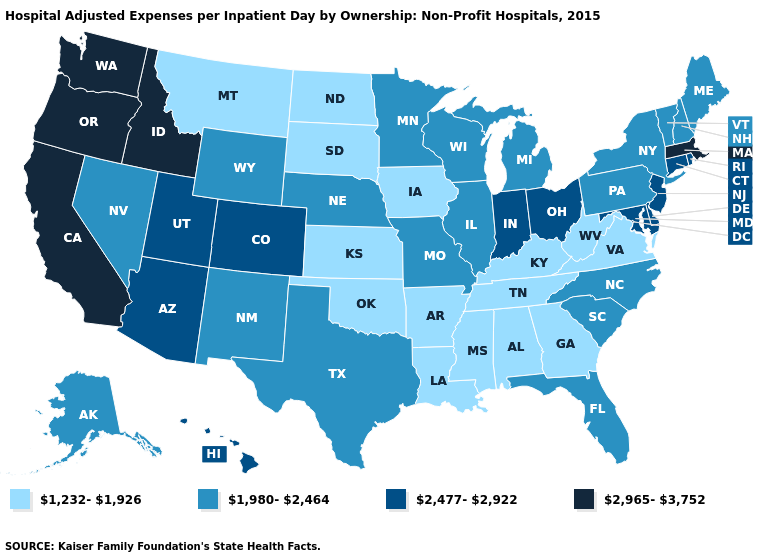Does New Jersey have the lowest value in the USA?
Be succinct. No. How many symbols are there in the legend?
Short answer required. 4. What is the highest value in the West ?
Be succinct. 2,965-3,752. Name the states that have a value in the range 2,477-2,922?
Write a very short answer. Arizona, Colorado, Connecticut, Delaware, Hawaii, Indiana, Maryland, New Jersey, Ohio, Rhode Island, Utah. Does Wisconsin have the lowest value in the USA?
Give a very brief answer. No. Does Kentucky have the same value as Arkansas?
Be succinct. Yes. Is the legend a continuous bar?
Write a very short answer. No. What is the lowest value in states that border Pennsylvania?
Short answer required. 1,232-1,926. What is the highest value in the West ?
Be succinct. 2,965-3,752. Name the states that have a value in the range 2,477-2,922?
Give a very brief answer. Arizona, Colorado, Connecticut, Delaware, Hawaii, Indiana, Maryland, New Jersey, Ohio, Rhode Island, Utah. Name the states that have a value in the range 2,965-3,752?
Quick response, please. California, Idaho, Massachusetts, Oregon, Washington. Among the states that border Illinois , does Wisconsin have the highest value?
Be succinct. No. What is the value of Massachusetts?
Keep it brief. 2,965-3,752. Name the states that have a value in the range 2,965-3,752?
Keep it brief. California, Idaho, Massachusetts, Oregon, Washington. Which states have the lowest value in the West?
Write a very short answer. Montana. 